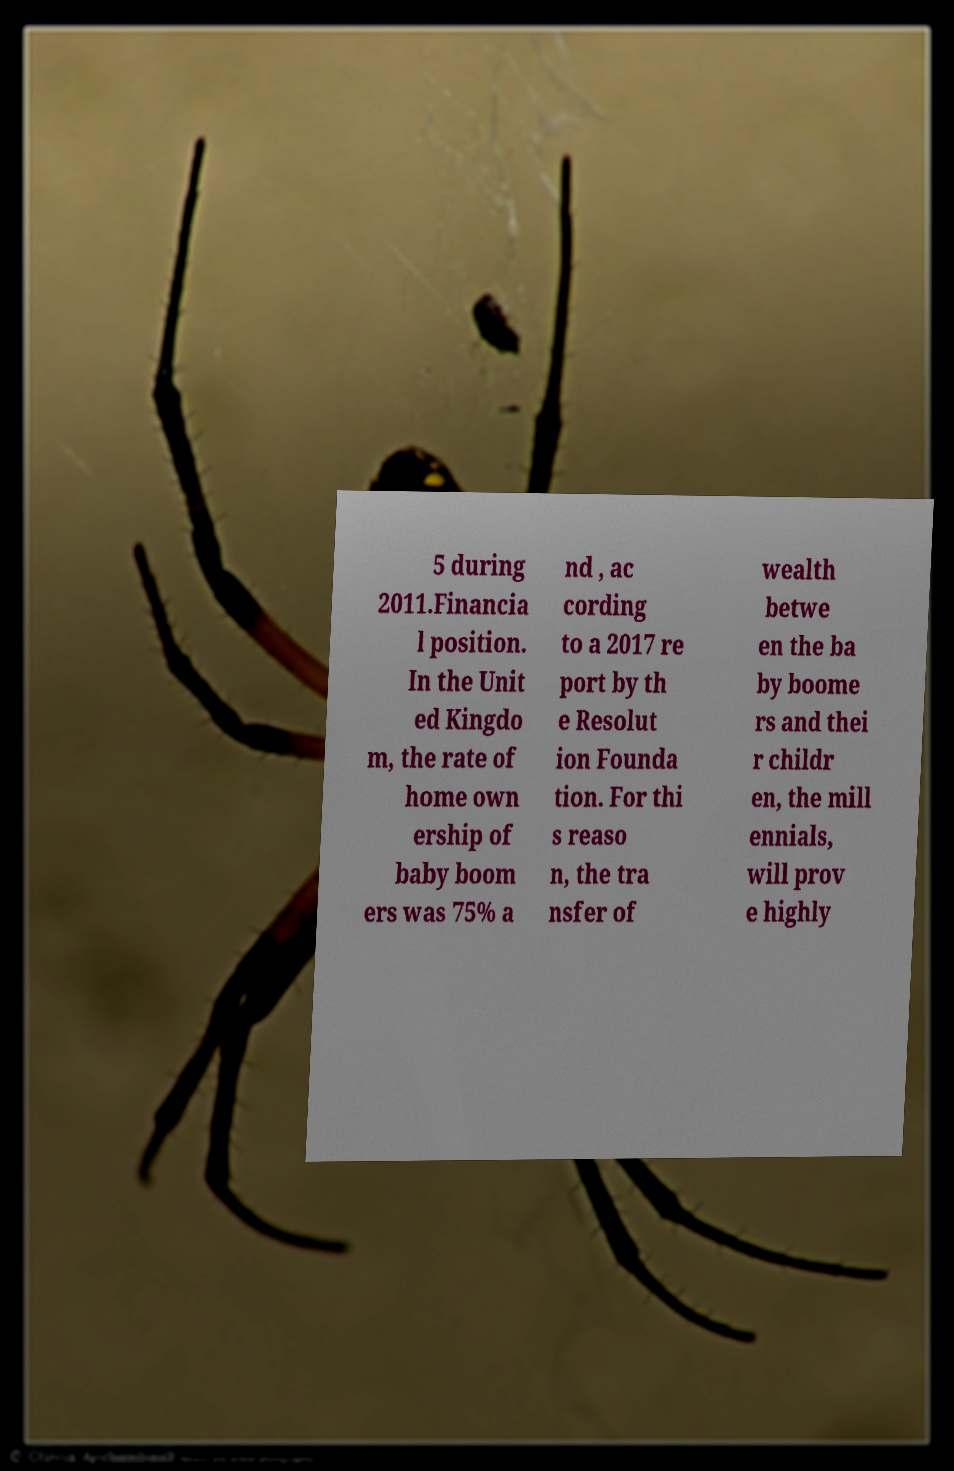What messages or text are displayed in this image? I need them in a readable, typed format. 5 during 2011.Financia l position. In the Unit ed Kingdo m, the rate of home own ership of baby boom ers was 75% a nd , ac cording to a 2017 re port by th e Resolut ion Founda tion. For thi s reaso n, the tra nsfer of wealth betwe en the ba by boome rs and thei r childr en, the mill ennials, will prov e highly 